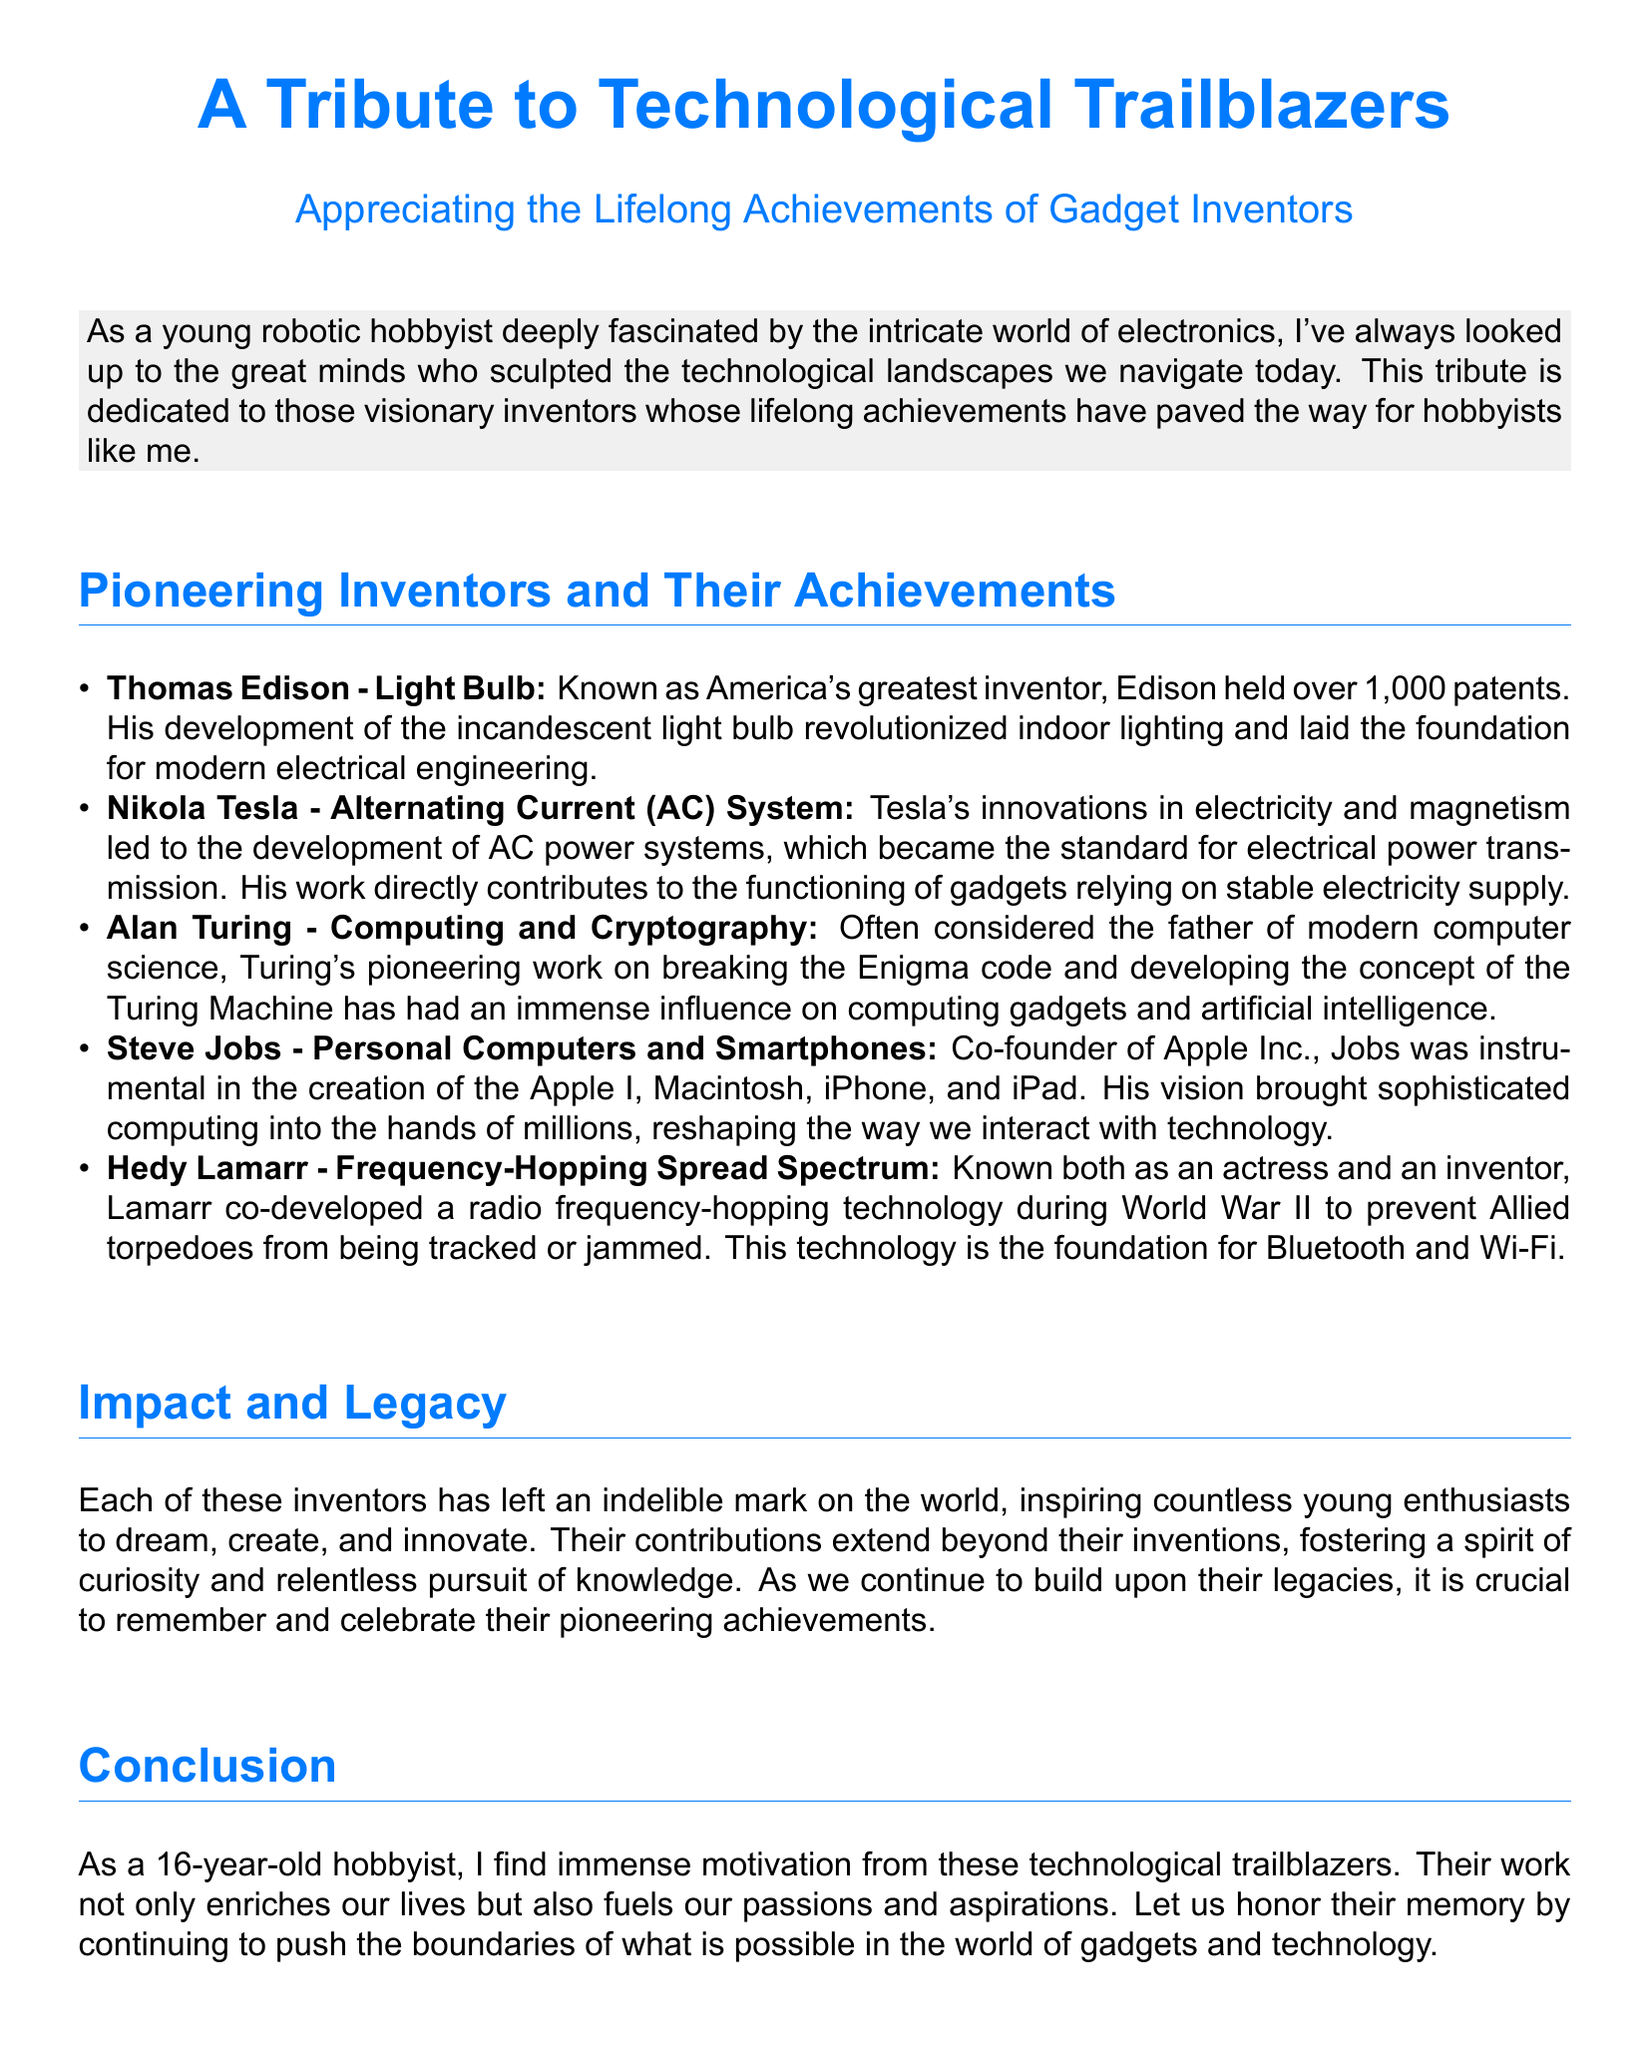What is the title of the tribute? The title of the tribute is mentioned at the beginning of the document.
Answer: A Tribute to Technological Trailblazers Who is known as America's greatest inventor? The document lists Thomas Edison as America's greatest inventor.
Answer: Thomas Edison What technology did Hedy Lamarr co-develop? The document states that Lamarr co-developed a specific technology during World War II.
Answer: Frequency-Hopping Spread Spectrum Who co-founded Apple Inc.? The document mentions a key figure in the personal computer revolution and the smartphone industry.
Answer: Steve Jobs What impact did these inventors have on young enthusiasts? The document describes the inspiration these inventors provide to hobbyists like the author.
Answer: Inspire countless young enthusiasts What is the primary focus of this tribute? The document emphasizes the achievements of specific inventors in technology and gadgets.
Answer: Lifelong Achievements of Gadget Inventors How many patents did Thomas Edison hold? The document states the number of patents held by Edison.
Answer: Over 1,000 patents What field is Alan Turing known for? The document tells that Turing is often considered the father of modern computer science.
Answer: Computing and Cryptography 